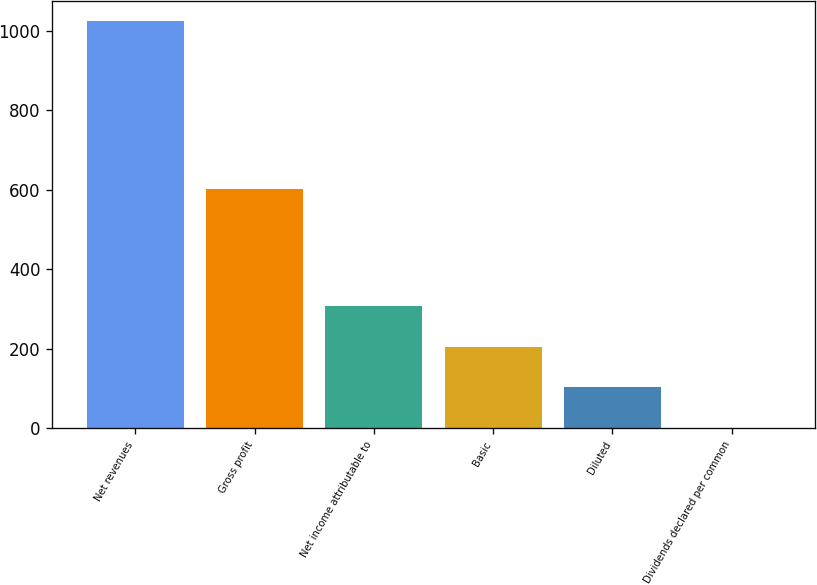Convert chart. <chart><loc_0><loc_0><loc_500><loc_500><bar_chart><fcel>Net revenues<fcel>Gross profit<fcel>Net income attributable to<fcel>Basic<fcel>Diluted<fcel>Dividends declared per common<nl><fcel>1023.7<fcel>601.2<fcel>307.15<fcel>204.79<fcel>102.42<fcel>0.05<nl></chart> 